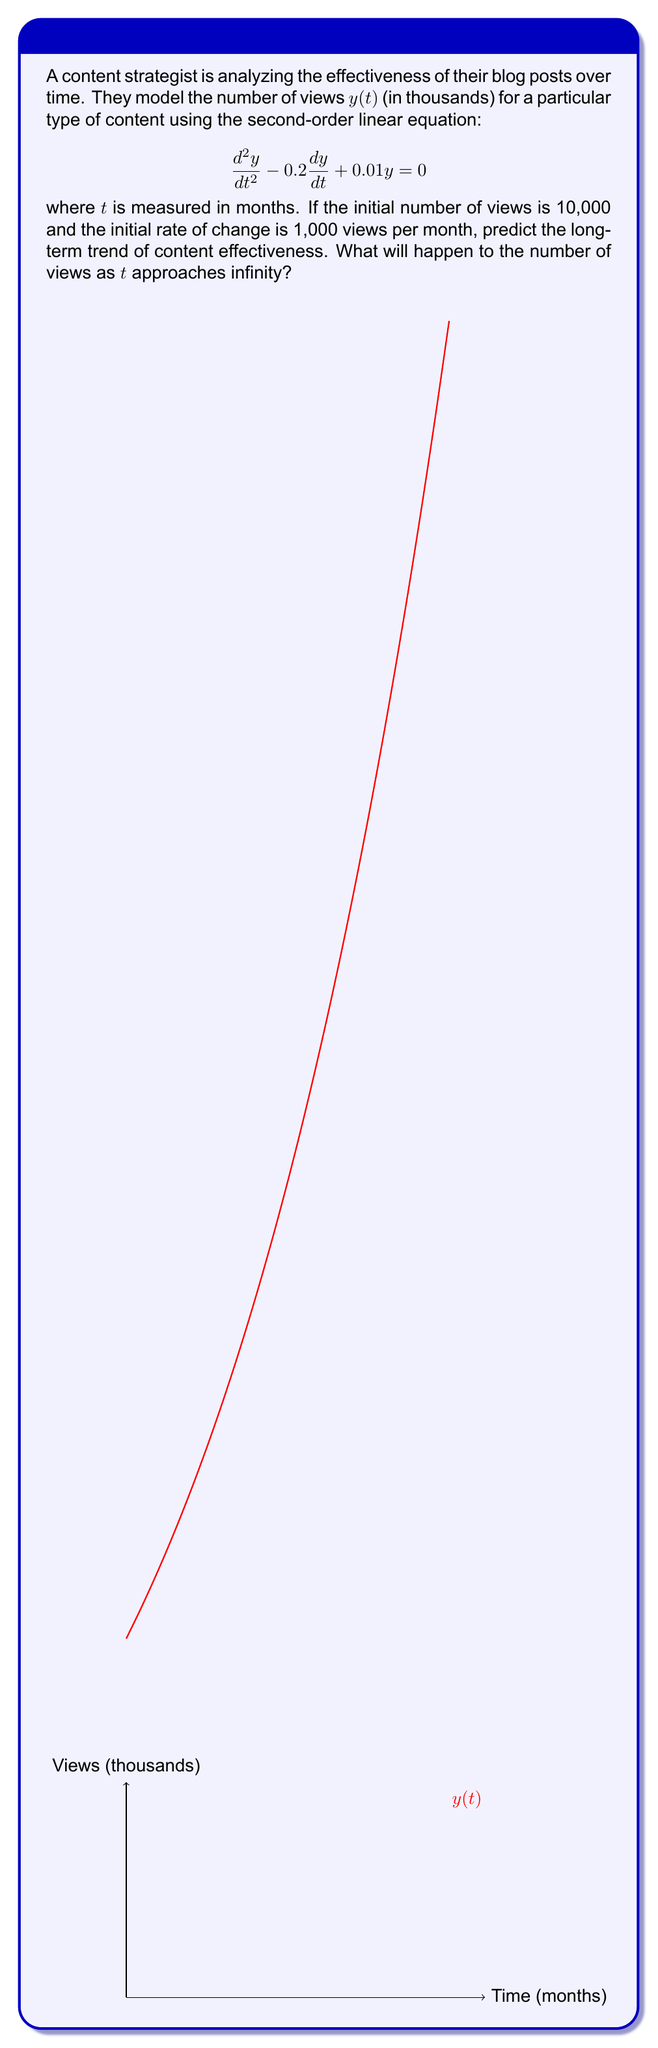Provide a solution to this math problem. To predict the long-term trend, we need to solve the given second-order linear equation:

1) The characteristic equation is: $r^2 - 0.2r + 0.01 = 0$

2) Solving this quadratic equation:
   $r = \frac{0.2 \pm \sqrt{0.04 - 0.04}}{2} = 0.1$

3) Since we have a repeated root, the general solution is:
   $y(t) = (C_1 + C_2t)e^{0.1t}$

4) Using the initial conditions:
   $y(0) = 10$ and $y'(0) = 1$

5) We can find $C_1$ and $C_2$:
   $C_1 = 10$ and $C_2 = 0.1$

6) Thus, the particular solution is:
   $y(t) = 10e^{0.1t}(1 + 0.1t)$

7) As $t$ approaches infinity, both $e^{0.1t}$ and $(1 + 0.1t)$ grow without bound.

Therefore, the long-term trend shows exponential growth in content effectiveness.
Answer: The number of views will grow exponentially as $t$ approaches infinity. 